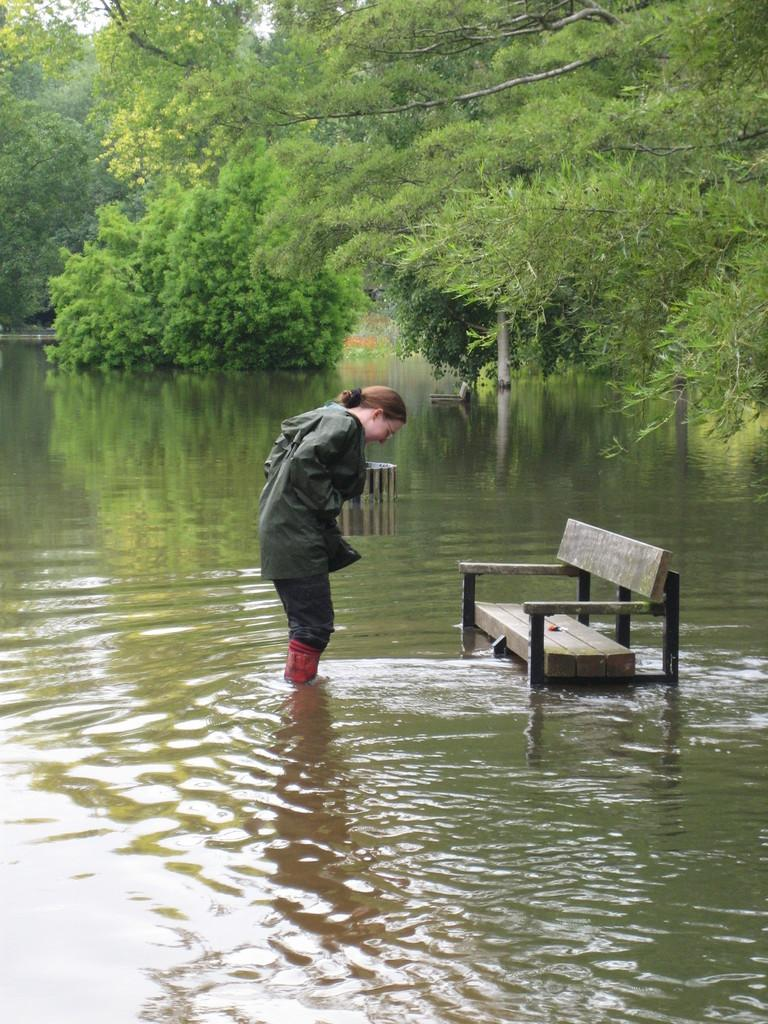Who is present in the image? There is a woman in the image. What is located on the right side of the image? There is a bench on the right side of the image. What can be seen in the background of the image? There are trees in the background of the image. What natural element is visible in the image? There is water visible in the image. What type of punishment is the woman receiving in the image? There is no indication of punishment in the image. 